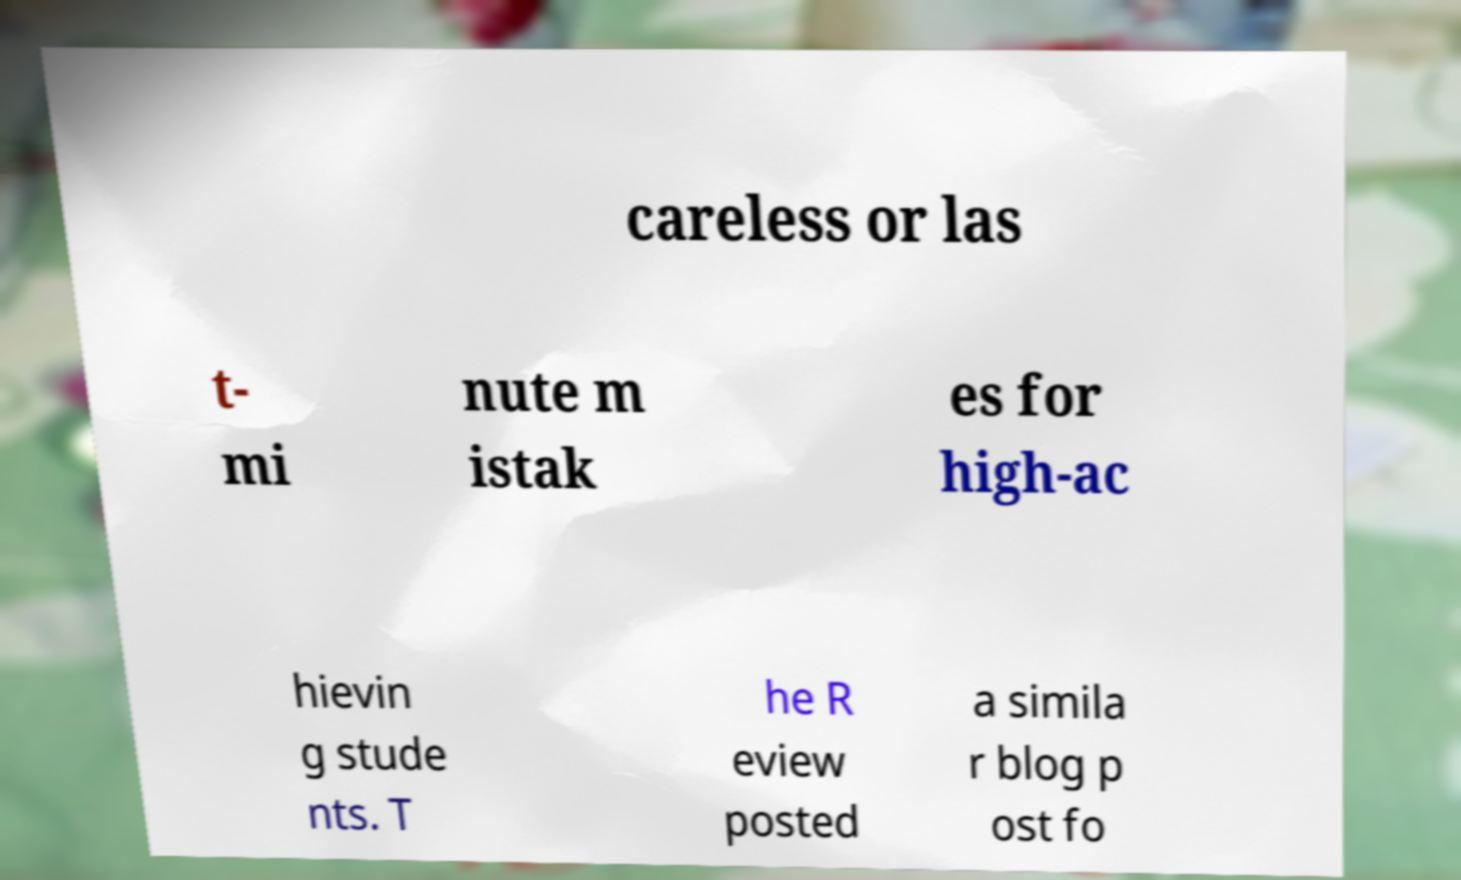There's text embedded in this image that I need extracted. Can you transcribe it verbatim? careless or las t- mi nute m istak es for high-ac hievin g stude nts. T he R eview posted a simila r blog p ost fo 